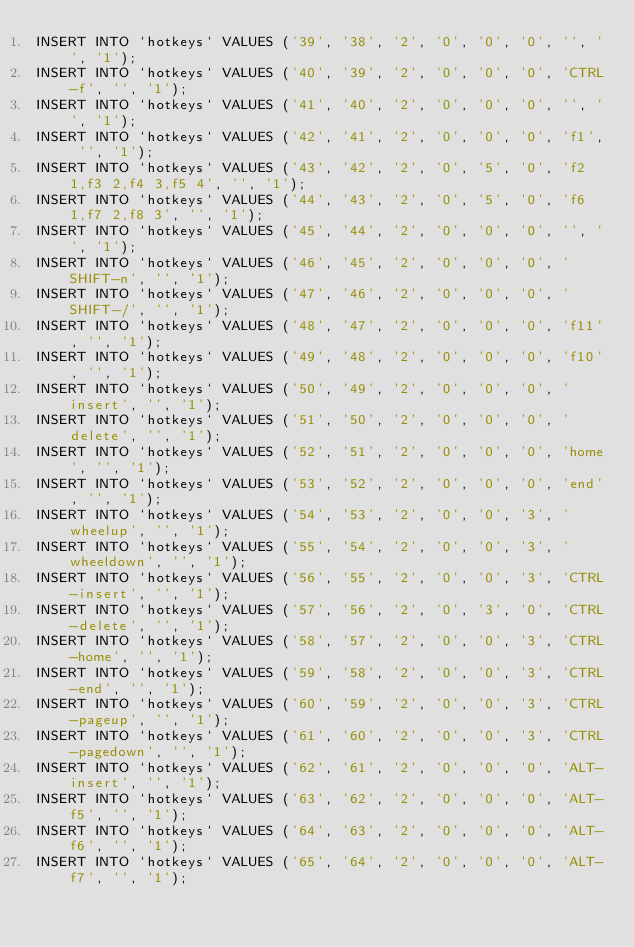Convert code to text. <code><loc_0><loc_0><loc_500><loc_500><_SQL_>INSERT INTO `hotkeys` VALUES ('39', '38', '2', '0', '0', '0', '', '', '1');
INSERT INTO `hotkeys` VALUES ('40', '39', '2', '0', '0', '0', 'CTRL-f', '', '1');
INSERT INTO `hotkeys` VALUES ('41', '40', '2', '0', '0', '0', '', '', '1');
INSERT INTO `hotkeys` VALUES ('42', '41', '2', '0', '0', '0', 'f1', '', '1');
INSERT INTO `hotkeys` VALUES ('43', '42', '2', '0', '5', '0', 'f2 1,f3 2,f4 3,f5 4', '', '1');
INSERT INTO `hotkeys` VALUES ('44', '43', '2', '0', '5', '0', 'f6 1,f7 2,f8 3', '', '1');
INSERT INTO `hotkeys` VALUES ('45', '44', '2', '0', '0', '0', '', '', '1');
INSERT INTO `hotkeys` VALUES ('46', '45', '2', '0', '0', '0', 'SHIFT-n', '', '1');
INSERT INTO `hotkeys` VALUES ('47', '46', '2', '0', '0', '0', 'SHIFT-/', '', '1');
INSERT INTO `hotkeys` VALUES ('48', '47', '2', '0', '0', '0', 'f11', '', '1');
INSERT INTO `hotkeys` VALUES ('49', '48', '2', '0', '0', '0', 'f10', '', '1');
INSERT INTO `hotkeys` VALUES ('50', '49', '2', '0', '0', '0', 'insert', '', '1');
INSERT INTO `hotkeys` VALUES ('51', '50', '2', '0', '0', '0', 'delete', '', '1');
INSERT INTO `hotkeys` VALUES ('52', '51', '2', '0', '0', '0', 'home', '', '1');
INSERT INTO `hotkeys` VALUES ('53', '52', '2', '0', '0', '0', 'end', '', '1');
INSERT INTO `hotkeys` VALUES ('54', '53', '2', '0', '0', '3', 'wheelup', '', '1');
INSERT INTO `hotkeys` VALUES ('55', '54', '2', '0', '0', '3', 'wheeldown', '', '1');
INSERT INTO `hotkeys` VALUES ('56', '55', '2', '0', '0', '3', 'CTRL-insert', '', '1');
INSERT INTO `hotkeys` VALUES ('57', '56', '2', '0', '3', '0', 'CTRL-delete', '', '1');
INSERT INTO `hotkeys` VALUES ('58', '57', '2', '0', '0', '3', 'CTRL-home', '', '1');
INSERT INTO `hotkeys` VALUES ('59', '58', '2', '0', '0', '3', 'CTRL-end', '', '1');
INSERT INTO `hotkeys` VALUES ('60', '59', '2', '0', '0', '3', 'CTRL-pageup', '', '1');
INSERT INTO `hotkeys` VALUES ('61', '60', '2', '0', '0', '3', 'CTRL-pagedown', '', '1');
INSERT INTO `hotkeys` VALUES ('62', '61', '2', '0', '0', '0', 'ALT-insert', '', '1');
INSERT INTO `hotkeys` VALUES ('63', '62', '2', '0', '0', '0', 'ALT-f5', '', '1');
INSERT INTO `hotkeys` VALUES ('64', '63', '2', '0', '0', '0', 'ALT-f6', '', '1');
INSERT INTO `hotkeys` VALUES ('65', '64', '2', '0', '0', '0', 'ALT-f7', '', '1');</code> 